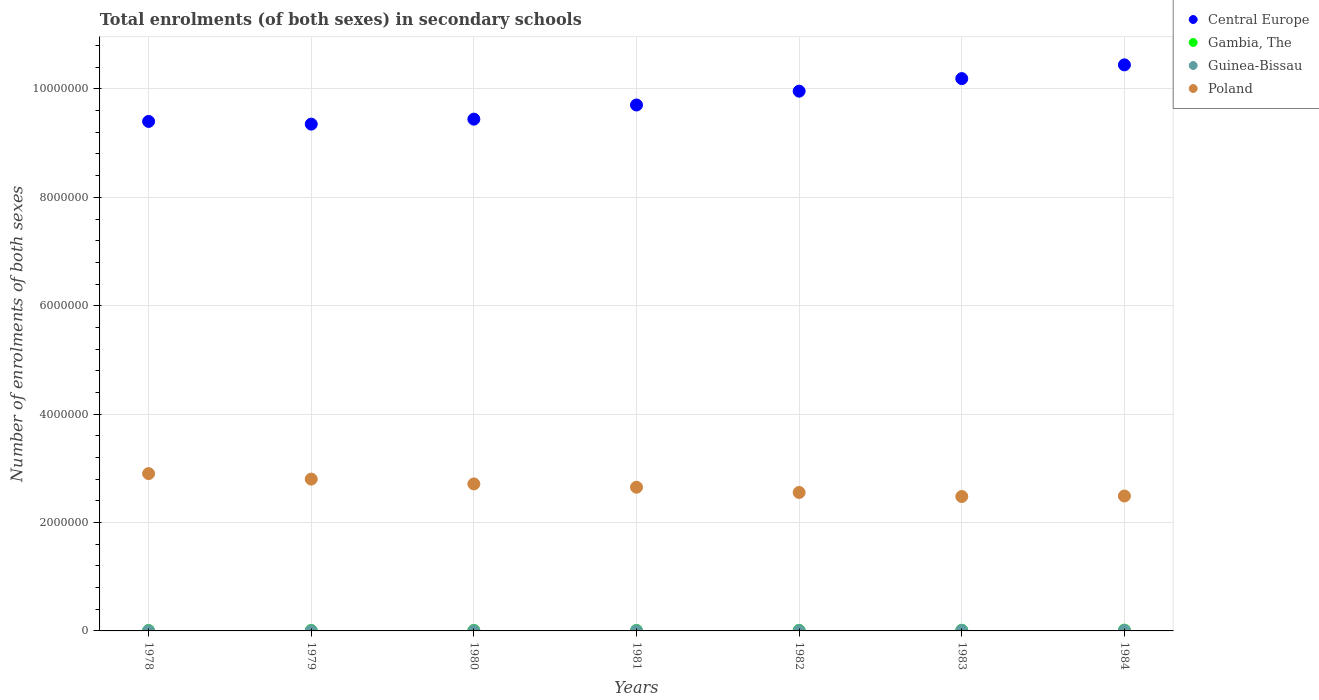How many different coloured dotlines are there?
Give a very brief answer. 4. Is the number of dotlines equal to the number of legend labels?
Offer a very short reply. Yes. What is the number of enrolments in secondary schools in Gambia, The in 1983?
Offer a very short reply. 1.24e+04. Across all years, what is the maximum number of enrolments in secondary schools in Gambia, The?
Ensure brevity in your answer.  1.44e+04. Across all years, what is the minimum number of enrolments in secondary schools in Central Europe?
Offer a terse response. 9.35e+06. In which year was the number of enrolments in secondary schools in Guinea-Bissau maximum?
Keep it short and to the point. 1984. In which year was the number of enrolments in secondary schools in Poland minimum?
Keep it short and to the point. 1983. What is the total number of enrolments in secondary schools in Central Europe in the graph?
Give a very brief answer. 6.85e+07. What is the difference between the number of enrolments in secondary schools in Guinea-Bissau in 1979 and that in 1983?
Make the answer very short. -4142. What is the difference between the number of enrolments in secondary schools in Central Europe in 1979 and the number of enrolments in secondary schools in Gambia, The in 1982?
Offer a very short reply. 9.34e+06. What is the average number of enrolments in secondary schools in Gambia, The per year?
Offer a very short reply. 1.02e+04. In the year 1983, what is the difference between the number of enrolments in secondary schools in Poland and number of enrolments in secondary schools in Central Europe?
Keep it short and to the point. -7.71e+06. In how many years, is the number of enrolments in secondary schools in Guinea-Bissau greater than 6000000?
Ensure brevity in your answer.  0. What is the ratio of the number of enrolments in secondary schools in Gambia, The in 1978 to that in 1982?
Offer a very short reply. 0.72. Is the difference between the number of enrolments in secondary schools in Poland in 1981 and 1984 greater than the difference between the number of enrolments in secondary schools in Central Europe in 1981 and 1984?
Your response must be concise. Yes. What is the difference between the highest and the second highest number of enrolments in secondary schools in Poland?
Make the answer very short. 1.01e+05. What is the difference between the highest and the lowest number of enrolments in secondary schools in Poland?
Provide a succinct answer. 4.22e+05. Is the sum of the number of enrolments in secondary schools in Gambia, The in 1978 and 1979 greater than the maximum number of enrolments in secondary schools in Poland across all years?
Offer a terse response. No. Is it the case that in every year, the sum of the number of enrolments in secondary schools in Guinea-Bissau and number of enrolments in secondary schools in Gambia, The  is greater than the number of enrolments in secondary schools in Central Europe?
Give a very brief answer. No. Does the number of enrolments in secondary schools in Gambia, The monotonically increase over the years?
Your answer should be very brief. Yes. Is the number of enrolments in secondary schools in Central Europe strictly greater than the number of enrolments in secondary schools in Guinea-Bissau over the years?
Offer a very short reply. Yes. Is the number of enrolments in secondary schools in Poland strictly less than the number of enrolments in secondary schools in Central Europe over the years?
Your answer should be compact. Yes. How many dotlines are there?
Ensure brevity in your answer.  4. How many years are there in the graph?
Your answer should be compact. 7. Does the graph contain any zero values?
Provide a short and direct response. No. Where does the legend appear in the graph?
Keep it short and to the point. Top right. How many legend labels are there?
Offer a very short reply. 4. How are the legend labels stacked?
Offer a very short reply. Vertical. What is the title of the graph?
Make the answer very short. Total enrolments (of both sexes) in secondary schools. Does "Saudi Arabia" appear as one of the legend labels in the graph?
Your response must be concise. No. What is the label or title of the X-axis?
Your response must be concise. Years. What is the label or title of the Y-axis?
Keep it short and to the point. Number of enrolments of both sexes. What is the Number of enrolments of both sexes in Central Europe in 1978?
Make the answer very short. 9.40e+06. What is the Number of enrolments of both sexes in Gambia, The in 1978?
Provide a succinct answer. 7588. What is the Number of enrolments of both sexes in Guinea-Bissau in 1978?
Keep it short and to the point. 3731. What is the Number of enrolments of both sexes of Poland in 1978?
Offer a very short reply. 2.90e+06. What is the Number of enrolments of both sexes of Central Europe in 1979?
Offer a terse response. 9.35e+06. What is the Number of enrolments of both sexes in Gambia, The in 1979?
Offer a terse response. 8101. What is the Number of enrolments of both sexes of Guinea-Bissau in 1979?
Make the answer very short. 4290. What is the Number of enrolments of both sexes in Poland in 1979?
Offer a terse response. 2.80e+06. What is the Number of enrolments of both sexes in Central Europe in 1980?
Give a very brief answer. 9.44e+06. What is the Number of enrolments of both sexes of Gambia, The in 1980?
Provide a short and direct response. 8940. What is the Number of enrolments of both sexes of Guinea-Bissau in 1980?
Ensure brevity in your answer.  4256. What is the Number of enrolments of both sexes in Poland in 1980?
Your response must be concise. 2.71e+06. What is the Number of enrolments of both sexes in Central Europe in 1981?
Offer a terse response. 9.70e+06. What is the Number of enrolments of both sexes of Gambia, The in 1981?
Keep it short and to the point. 9657. What is the Number of enrolments of both sexes of Guinea-Bissau in 1981?
Your answer should be very brief. 4757. What is the Number of enrolments of both sexes of Poland in 1981?
Keep it short and to the point. 2.65e+06. What is the Number of enrolments of both sexes of Central Europe in 1982?
Give a very brief answer. 9.96e+06. What is the Number of enrolments of both sexes of Gambia, The in 1982?
Keep it short and to the point. 1.06e+04. What is the Number of enrolments of both sexes in Guinea-Bissau in 1982?
Offer a terse response. 6294. What is the Number of enrolments of both sexes of Poland in 1982?
Offer a very short reply. 2.55e+06. What is the Number of enrolments of both sexes of Central Europe in 1983?
Make the answer very short. 1.02e+07. What is the Number of enrolments of both sexes of Gambia, The in 1983?
Keep it short and to the point. 1.24e+04. What is the Number of enrolments of both sexes in Guinea-Bissau in 1983?
Your answer should be very brief. 8432. What is the Number of enrolments of both sexes in Poland in 1983?
Your answer should be compact. 2.48e+06. What is the Number of enrolments of both sexes in Central Europe in 1984?
Your answer should be compact. 1.04e+07. What is the Number of enrolments of both sexes of Gambia, The in 1984?
Your answer should be compact. 1.44e+04. What is the Number of enrolments of both sexes of Guinea-Bissau in 1984?
Your answer should be very brief. 9634. What is the Number of enrolments of both sexes in Poland in 1984?
Ensure brevity in your answer.  2.49e+06. Across all years, what is the maximum Number of enrolments of both sexes of Central Europe?
Your answer should be very brief. 1.04e+07. Across all years, what is the maximum Number of enrolments of both sexes of Gambia, The?
Provide a short and direct response. 1.44e+04. Across all years, what is the maximum Number of enrolments of both sexes in Guinea-Bissau?
Provide a succinct answer. 9634. Across all years, what is the maximum Number of enrolments of both sexes of Poland?
Give a very brief answer. 2.90e+06. Across all years, what is the minimum Number of enrolments of both sexes of Central Europe?
Keep it short and to the point. 9.35e+06. Across all years, what is the minimum Number of enrolments of both sexes of Gambia, The?
Offer a very short reply. 7588. Across all years, what is the minimum Number of enrolments of both sexes in Guinea-Bissau?
Make the answer very short. 3731. Across all years, what is the minimum Number of enrolments of both sexes in Poland?
Your answer should be compact. 2.48e+06. What is the total Number of enrolments of both sexes in Central Europe in the graph?
Provide a succinct answer. 6.85e+07. What is the total Number of enrolments of both sexes of Gambia, The in the graph?
Ensure brevity in your answer.  7.17e+04. What is the total Number of enrolments of both sexes in Guinea-Bissau in the graph?
Make the answer very short. 4.14e+04. What is the total Number of enrolments of both sexes of Poland in the graph?
Offer a very short reply. 1.86e+07. What is the difference between the Number of enrolments of both sexes of Central Europe in 1978 and that in 1979?
Provide a short and direct response. 4.96e+04. What is the difference between the Number of enrolments of both sexes in Gambia, The in 1978 and that in 1979?
Ensure brevity in your answer.  -513. What is the difference between the Number of enrolments of both sexes in Guinea-Bissau in 1978 and that in 1979?
Ensure brevity in your answer.  -559. What is the difference between the Number of enrolments of both sexes of Poland in 1978 and that in 1979?
Your answer should be very brief. 1.01e+05. What is the difference between the Number of enrolments of both sexes in Central Europe in 1978 and that in 1980?
Make the answer very short. -4.21e+04. What is the difference between the Number of enrolments of both sexes of Gambia, The in 1978 and that in 1980?
Provide a short and direct response. -1352. What is the difference between the Number of enrolments of both sexes in Guinea-Bissau in 1978 and that in 1980?
Ensure brevity in your answer.  -525. What is the difference between the Number of enrolments of both sexes of Poland in 1978 and that in 1980?
Give a very brief answer. 1.90e+05. What is the difference between the Number of enrolments of both sexes in Central Europe in 1978 and that in 1981?
Make the answer very short. -3.03e+05. What is the difference between the Number of enrolments of both sexes of Gambia, The in 1978 and that in 1981?
Give a very brief answer. -2069. What is the difference between the Number of enrolments of both sexes of Guinea-Bissau in 1978 and that in 1981?
Provide a short and direct response. -1026. What is the difference between the Number of enrolments of both sexes in Poland in 1978 and that in 1981?
Provide a short and direct response. 2.51e+05. What is the difference between the Number of enrolments of both sexes in Central Europe in 1978 and that in 1982?
Provide a short and direct response. -5.59e+05. What is the difference between the Number of enrolments of both sexes in Gambia, The in 1978 and that in 1982?
Provide a succinct answer. -2981. What is the difference between the Number of enrolments of both sexes in Guinea-Bissau in 1978 and that in 1982?
Offer a terse response. -2563. What is the difference between the Number of enrolments of both sexes in Poland in 1978 and that in 1982?
Your answer should be compact. 3.48e+05. What is the difference between the Number of enrolments of both sexes of Central Europe in 1978 and that in 1983?
Your answer should be very brief. -7.90e+05. What is the difference between the Number of enrolments of both sexes in Gambia, The in 1978 and that in 1983?
Make the answer very short. -4836. What is the difference between the Number of enrolments of both sexes of Guinea-Bissau in 1978 and that in 1983?
Ensure brevity in your answer.  -4701. What is the difference between the Number of enrolments of both sexes in Poland in 1978 and that in 1983?
Provide a short and direct response. 4.22e+05. What is the difference between the Number of enrolments of both sexes of Central Europe in 1978 and that in 1984?
Provide a short and direct response. -1.04e+06. What is the difference between the Number of enrolments of both sexes in Gambia, The in 1978 and that in 1984?
Your answer should be compact. -6842. What is the difference between the Number of enrolments of both sexes in Guinea-Bissau in 1978 and that in 1984?
Offer a terse response. -5903. What is the difference between the Number of enrolments of both sexes in Poland in 1978 and that in 1984?
Make the answer very short. 4.13e+05. What is the difference between the Number of enrolments of both sexes of Central Europe in 1979 and that in 1980?
Give a very brief answer. -9.18e+04. What is the difference between the Number of enrolments of both sexes in Gambia, The in 1979 and that in 1980?
Your response must be concise. -839. What is the difference between the Number of enrolments of both sexes in Poland in 1979 and that in 1980?
Provide a short and direct response. 8.89e+04. What is the difference between the Number of enrolments of both sexes in Central Europe in 1979 and that in 1981?
Offer a very short reply. -3.53e+05. What is the difference between the Number of enrolments of both sexes in Gambia, The in 1979 and that in 1981?
Ensure brevity in your answer.  -1556. What is the difference between the Number of enrolments of both sexes of Guinea-Bissau in 1979 and that in 1981?
Give a very brief answer. -467. What is the difference between the Number of enrolments of both sexes of Poland in 1979 and that in 1981?
Your answer should be compact. 1.50e+05. What is the difference between the Number of enrolments of both sexes in Central Europe in 1979 and that in 1982?
Keep it short and to the point. -6.08e+05. What is the difference between the Number of enrolments of both sexes in Gambia, The in 1979 and that in 1982?
Provide a short and direct response. -2468. What is the difference between the Number of enrolments of both sexes in Guinea-Bissau in 1979 and that in 1982?
Offer a terse response. -2004. What is the difference between the Number of enrolments of both sexes of Poland in 1979 and that in 1982?
Your response must be concise. 2.47e+05. What is the difference between the Number of enrolments of both sexes of Central Europe in 1979 and that in 1983?
Provide a succinct answer. -8.40e+05. What is the difference between the Number of enrolments of both sexes of Gambia, The in 1979 and that in 1983?
Your response must be concise. -4323. What is the difference between the Number of enrolments of both sexes in Guinea-Bissau in 1979 and that in 1983?
Provide a succinct answer. -4142. What is the difference between the Number of enrolments of both sexes in Poland in 1979 and that in 1983?
Your response must be concise. 3.21e+05. What is the difference between the Number of enrolments of both sexes of Central Europe in 1979 and that in 1984?
Provide a short and direct response. -1.09e+06. What is the difference between the Number of enrolments of both sexes of Gambia, The in 1979 and that in 1984?
Keep it short and to the point. -6329. What is the difference between the Number of enrolments of both sexes in Guinea-Bissau in 1979 and that in 1984?
Your answer should be compact. -5344. What is the difference between the Number of enrolments of both sexes in Poland in 1979 and that in 1984?
Your answer should be compact. 3.12e+05. What is the difference between the Number of enrolments of both sexes in Central Europe in 1980 and that in 1981?
Offer a very short reply. -2.61e+05. What is the difference between the Number of enrolments of both sexes of Gambia, The in 1980 and that in 1981?
Provide a succinct answer. -717. What is the difference between the Number of enrolments of both sexes in Guinea-Bissau in 1980 and that in 1981?
Offer a very short reply. -501. What is the difference between the Number of enrolments of both sexes of Poland in 1980 and that in 1981?
Ensure brevity in your answer.  6.11e+04. What is the difference between the Number of enrolments of both sexes of Central Europe in 1980 and that in 1982?
Keep it short and to the point. -5.16e+05. What is the difference between the Number of enrolments of both sexes in Gambia, The in 1980 and that in 1982?
Offer a very short reply. -1629. What is the difference between the Number of enrolments of both sexes in Guinea-Bissau in 1980 and that in 1982?
Give a very brief answer. -2038. What is the difference between the Number of enrolments of both sexes in Poland in 1980 and that in 1982?
Give a very brief answer. 1.58e+05. What is the difference between the Number of enrolments of both sexes of Central Europe in 1980 and that in 1983?
Keep it short and to the point. -7.48e+05. What is the difference between the Number of enrolments of both sexes of Gambia, The in 1980 and that in 1983?
Offer a very short reply. -3484. What is the difference between the Number of enrolments of both sexes in Guinea-Bissau in 1980 and that in 1983?
Offer a very short reply. -4176. What is the difference between the Number of enrolments of both sexes of Poland in 1980 and that in 1983?
Give a very brief answer. 2.32e+05. What is the difference between the Number of enrolments of both sexes in Central Europe in 1980 and that in 1984?
Give a very brief answer. -1.00e+06. What is the difference between the Number of enrolments of both sexes of Gambia, The in 1980 and that in 1984?
Your response must be concise. -5490. What is the difference between the Number of enrolments of both sexes in Guinea-Bissau in 1980 and that in 1984?
Make the answer very short. -5378. What is the difference between the Number of enrolments of both sexes in Poland in 1980 and that in 1984?
Ensure brevity in your answer.  2.23e+05. What is the difference between the Number of enrolments of both sexes in Central Europe in 1981 and that in 1982?
Make the answer very short. -2.55e+05. What is the difference between the Number of enrolments of both sexes of Gambia, The in 1981 and that in 1982?
Your response must be concise. -912. What is the difference between the Number of enrolments of both sexes in Guinea-Bissau in 1981 and that in 1982?
Your response must be concise. -1537. What is the difference between the Number of enrolments of both sexes of Poland in 1981 and that in 1982?
Your response must be concise. 9.65e+04. What is the difference between the Number of enrolments of both sexes in Central Europe in 1981 and that in 1983?
Offer a terse response. -4.87e+05. What is the difference between the Number of enrolments of both sexes of Gambia, The in 1981 and that in 1983?
Provide a succinct answer. -2767. What is the difference between the Number of enrolments of both sexes in Guinea-Bissau in 1981 and that in 1983?
Your answer should be compact. -3675. What is the difference between the Number of enrolments of both sexes in Poland in 1981 and that in 1983?
Give a very brief answer. 1.71e+05. What is the difference between the Number of enrolments of both sexes of Central Europe in 1981 and that in 1984?
Provide a short and direct response. -7.40e+05. What is the difference between the Number of enrolments of both sexes of Gambia, The in 1981 and that in 1984?
Your answer should be compact. -4773. What is the difference between the Number of enrolments of both sexes in Guinea-Bissau in 1981 and that in 1984?
Your answer should be very brief. -4877. What is the difference between the Number of enrolments of both sexes in Poland in 1981 and that in 1984?
Your answer should be very brief. 1.62e+05. What is the difference between the Number of enrolments of both sexes in Central Europe in 1982 and that in 1983?
Your response must be concise. -2.32e+05. What is the difference between the Number of enrolments of both sexes of Gambia, The in 1982 and that in 1983?
Your answer should be very brief. -1855. What is the difference between the Number of enrolments of both sexes of Guinea-Bissau in 1982 and that in 1983?
Keep it short and to the point. -2138. What is the difference between the Number of enrolments of both sexes of Poland in 1982 and that in 1983?
Your response must be concise. 7.42e+04. What is the difference between the Number of enrolments of both sexes in Central Europe in 1982 and that in 1984?
Make the answer very short. -4.85e+05. What is the difference between the Number of enrolments of both sexes of Gambia, The in 1982 and that in 1984?
Provide a short and direct response. -3861. What is the difference between the Number of enrolments of both sexes of Guinea-Bissau in 1982 and that in 1984?
Make the answer very short. -3340. What is the difference between the Number of enrolments of both sexes of Poland in 1982 and that in 1984?
Make the answer very short. 6.54e+04. What is the difference between the Number of enrolments of both sexes in Central Europe in 1983 and that in 1984?
Make the answer very short. -2.53e+05. What is the difference between the Number of enrolments of both sexes in Gambia, The in 1983 and that in 1984?
Keep it short and to the point. -2006. What is the difference between the Number of enrolments of both sexes in Guinea-Bissau in 1983 and that in 1984?
Provide a short and direct response. -1202. What is the difference between the Number of enrolments of both sexes of Poland in 1983 and that in 1984?
Your answer should be very brief. -8840. What is the difference between the Number of enrolments of both sexes of Central Europe in 1978 and the Number of enrolments of both sexes of Gambia, The in 1979?
Provide a succinct answer. 9.39e+06. What is the difference between the Number of enrolments of both sexes in Central Europe in 1978 and the Number of enrolments of both sexes in Guinea-Bissau in 1979?
Your response must be concise. 9.40e+06. What is the difference between the Number of enrolments of both sexes in Central Europe in 1978 and the Number of enrolments of both sexes in Poland in 1979?
Give a very brief answer. 6.60e+06. What is the difference between the Number of enrolments of both sexes in Gambia, The in 1978 and the Number of enrolments of both sexes in Guinea-Bissau in 1979?
Your response must be concise. 3298. What is the difference between the Number of enrolments of both sexes in Gambia, The in 1978 and the Number of enrolments of both sexes in Poland in 1979?
Give a very brief answer. -2.79e+06. What is the difference between the Number of enrolments of both sexes in Guinea-Bissau in 1978 and the Number of enrolments of both sexes in Poland in 1979?
Give a very brief answer. -2.80e+06. What is the difference between the Number of enrolments of both sexes in Central Europe in 1978 and the Number of enrolments of both sexes in Gambia, The in 1980?
Your response must be concise. 9.39e+06. What is the difference between the Number of enrolments of both sexes in Central Europe in 1978 and the Number of enrolments of both sexes in Guinea-Bissau in 1980?
Provide a succinct answer. 9.40e+06. What is the difference between the Number of enrolments of both sexes in Central Europe in 1978 and the Number of enrolments of both sexes in Poland in 1980?
Provide a succinct answer. 6.69e+06. What is the difference between the Number of enrolments of both sexes in Gambia, The in 1978 and the Number of enrolments of both sexes in Guinea-Bissau in 1980?
Your answer should be compact. 3332. What is the difference between the Number of enrolments of both sexes of Gambia, The in 1978 and the Number of enrolments of both sexes of Poland in 1980?
Your answer should be very brief. -2.70e+06. What is the difference between the Number of enrolments of both sexes of Guinea-Bissau in 1978 and the Number of enrolments of both sexes of Poland in 1980?
Ensure brevity in your answer.  -2.71e+06. What is the difference between the Number of enrolments of both sexes in Central Europe in 1978 and the Number of enrolments of both sexes in Gambia, The in 1981?
Your response must be concise. 9.39e+06. What is the difference between the Number of enrolments of both sexes of Central Europe in 1978 and the Number of enrolments of both sexes of Guinea-Bissau in 1981?
Your answer should be compact. 9.40e+06. What is the difference between the Number of enrolments of both sexes of Central Europe in 1978 and the Number of enrolments of both sexes of Poland in 1981?
Provide a short and direct response. 6.75e+06. What is the difference between the Number of enrolments of both sexes of Gambia, The in 1978 and the Number of enrolments of both sexes of Guinea-Bissau in 1981?
Offer a terse response. 2831. What is the difference between the Number of enrolments of both sexes in Gambia, The in 1978 and the Number of enrolments of both sexes in Poland in 1981?
Your response must be concise. -2.64e+06. What is the difference between the Number of enrolments of both sexes of Guinea-Bissau in 1978 and the Number of enrolments of both sexes of Poland in 1981?
Offer a very short reply. -2.65e+06. What is the difference between the Number of enrolments of both sexes in Central Europe in 1978 and the Number of enrolments of both sexes in Gambia, The in 1982?
Make the answer very short. 9.39e+06. What is the difference between the Number of enrolments of both sexes in Central Europe in 1978 and the Number of enrolments of both sexes in Guinea-Bissau in 1982?
Offer a terse response. 9.39e+06. What is the difference between the Number of enrolments of both sexes of Central Europe in 1978 and the Number of enrolments of both sexes of Poland in 1982?
Offer a very short reply. 6.85e+06. What is the difference between the Number of enrolments of both sexes in Gambia, The in 1978 and the Number of enrolments of both sexes in Guinea-Bissau in 1982?
Keep it short and to the point. 1294. What is the difference between the Number of enrolments of both sexes in Gambia, The in 1978 and the Number of enrolments of both sexes in Poland in 1982?
Make the answer very short. -2.55e+06. What is the difference between the Number of enrolments of both sexes in Guinea-Bissau in 1978 and the Number of enrolments of both sexes in Poland in 1982?
Your response must be concise. -2.55e+06. What is the difference between the Number of enrolments of both sexes of Central Europe in 1978 and the Number of enrolments of both sexes of Gambia, The in 1983?
Your answer should be compact. 9.39e+06. What is the difference between the Number of enrolments of both sexes of Central Europe in 1978 and the Number of enrolments of both sexes of Guinea-Bissau in 1983?
Provide a short and direct response. 9.39e+06. What is the difference between the Number of enrolments of both sexes in Central Europe in 1978 and the Number of enrolments of both sexes in Poland in 1983?
Keep it short and to the point. 6.92e+06. What is the difference between the Number of enrolments of both sexes in Gambia, The in 1978 and the Number of enrolments of both sexes in Guinea-Bissau in 1983?
Your response must be concise. -844. What is the difference between the Number of enrolments of both sexes in Gambia, The in 1978 and the Number of enrolments of both sexes in Poland in 1983?
Make the answer very short. -2.47e+06. What is the difference between the Number of enrolments of both sexes in Guinea-Bissau in 1978 and the Number of enrolments of both sexes in Poland in 1983?
Offer a very short reply. -2.48e+06. What is the difference between the Number of enrolments of both sexes in Central Europe in 1978 and the Number of enrolments of both sexes in Gambia, The in 1984?
Keep it short and to the point. 9.39e+06. What is the difference between the Number of enrolments of both sexes in Central Europe in 1978 and the Number of enrolments of both sexes in Guinea-Bissau in 1984?
Provide a succinct answer. 9.39e+06. What is the difference between the Number of enrolments of both sexes in Central Europe in 1978 and the Number of enrolments of both sexes in Poland in 1984?
Your answer should be very brief. 6.91e+06. What is the difference between the Number of enrolments of both sexes in Gambia, The in 1978 and the Number of enrolments of both sexes in Guinea-Bissau in 1984?
Your answer should be very brief. -2046. What is the difference between the Number of enrolments of both sexes in Gambia, The in 1978 and the Number of enrolments of both sexes in Poland in 1984?
Give a very brief answer. -2.48e+06. What is the difference between the Number of enrolments of both sexes of Guinea-Bissau in 1978 and the Number of enrolments of both sexes of Poland in 1984?
Your answer should be very brief. -2.49e+06. What is the difference between the Number of enrolments of both sexes of Central Europe in 1979 and the Number of enrolments of both sexes of Gambia, The in 1980?
Offer a very short reply. 9.34e+06. What is the difference between the Number of enrolments of both sexes of Central Europe in 1979 and the Number of enrolments of both sexes of Guinea-Bissau in 1980?
Offer a terse response. 9.35e+06. What is the difference between the Number of enrolments of both sexes in Central Europe in 1979 and the Number of enrolments of both sexes in Poland in 1980?
Provide a succinct answer. 6.64e+06. What is the difference between the Number of enrolments of both sexes in Gambia, The in 1979 and the Number of enrolments of both sexes in Guinea-Bissau in 1980?
Your response must be concise. 3845. What is the difference between the Number of enrolments of both sexes of Gambia, The in 1979 and the Number of enrolments of both sexes of Poland in 1980?
Give a very brief answer. -2.70e+06. What is the difference between the Number of enrolments of both sexes in Guinea-Bissau in 1979 and the Number of enrolments of both sexes in Poland in 1980?
Keep it short and to the point. -2.71e+06. What is the difference between the Number of enrolments of both sexes of Central Europe in 1979 and the Number of enrolments of both sexes of Gambia, The in 1981?
Your answer should be very brief. 9.34e+06. What is the difference between the Number of enrolments of both sexes in Central Europe in 1979 and the Number of enrolments of both sexes in Guinea-Bissau in 1981?
Give a very brief answer. 9.35e+06. What is the difference between the Number of enrolments of both sexes of Central Europe in 1979 and the Number of enrolments of both sexes of Poland in 1981?
Provide a short and direct response. 6.70e+06. What is the difference between the Number of enrolments of both sexes in Gambia, The in 1979 and the Number of enrolments of both sexes in Guinea-Bissau in 1981?
Keep it short and to the point. 3344. What is the difference between the Number of enrolments of both sexes in Gambia, The in 1979 and the Number of enrolments of both sexes in Poland in 1981?
Provide a short and direct response. -2.64e+06. What is the difference between the Number of enrolments of both sexes of Guinea-Bissau in 1979 and the Number of enrolments of both sexes of Poland in 1981?
Ensure brevity in your answer.  -2.65e+06. What is the difference between the Number of enrolments of both sexes of Central Europe in 1979 and the Number of enrolments of both sexes of Gambia, The in 1982?
Make the answer very short. 9.34e+06. What is the difference between the Number of enrolments of both sexes in Central Europe in 1979 and the Number of enrolments of both sexes in Guinea-Bissau in 1982?
Provide a short and direct response. 9.34e+06. What is the difference between the Number of enrolments of both sexes in Central Europe in 1979 and the Number of enrolments of both sexes in Poland in 1982?
Your answer should be very brief. 6.80e+06. What is the difference between the Number of enrolments of both sexes of Gambia, The in 1979 and the Number of enrolments of both sexes of Guinea-Bissau in 1982?
Provide a short and direct response. 1807. What is the difference between the Number of enrolments of both sexes of Gambia, The in 1979 and the Number of enrolments of both sexes of Poland in 1982?
Your answer should be compact. -2.55e+06. What is the difference between the Number of enrolments of both sexes in Guinea-Bissau in 1979 and the Number of enrolments of both sexes in Poland in 1982?
Ensure brevity in your answer.  -2.55e+06. What is the difference between the Number of enrolments of both sexes in Central Europe in 1979 and the Number of enrolments of both sexes in Gambia, The in 1983?
Your response must be concise. 9.34e+06. What is the difference between the Number of enrolments of both sexes of Central Europe in 1979 and the Number of enrolments of both sexes of Guinea-Bissau in 1983?
Your response must be concise. 9.34e+06. What is the difference between the Number of enrolments of both sexes of Central Europe in 1979 and the Number of enrolments of both sexes of Poland in 1983?
Provide a succinct answer. 6.87e+06. What is the difference between the Number of enrolments of both sexes in Gambia, The in 1979 and the Number of enrolments of both sexes in Guinea-Bissau in 1983?
Provide a succinct answer. -331. What is the difference between the Number of enrolments of both sexes of Gambia, The in 1979 and the Number of enrolments of both sexes of Poland in 1983?
Your response must be concise. -2.47e+06. What is the difference between the Number of enrolments of both sexes in Guinea-Bissau in 1979 and the Number of enrolments of both sexes in Poland in 1983?
Ensure brevity in your answer.  -2.48e+06. What is the difference between the Number of enrolments of both sexes of Central Europe in 1979 and the Number of enrolments of both sexes of Gambia, The in 1984?
Make the answer very short. 9.34e+06. What is the difference between the Number of enrolments of both sexes in Central Europe in 1979 and the Number of enrolments of both sexes in Guinea-Bissau in 1984?
Offer a very short reply. 9.34e+06. What is the difference between the Number of enrolments of both sexes of Central Europe in 1979 and the Number of enrolments of both sexes of Poland in 1984?
Your answer should be compact. 6.86e+06. What is the difference between the Number of enrolments of both sexes in Gambia, The in 1979 and the Number of enrolments of both sexes in Guinea-Bissau in 1984?
Offer a terse response. -1533. What is the difference between the Number of enrolments of both sexes in Gambia, The in 1979 and the Number of enrolments of both sexes in Poland in 1984?
Provide a succinct answer. -2.48e+06. What is the difference between the Number of enrolments of both sexes in Guinea-Bissau in 1979 and the Number of enrolments of both sexes in Poland in 1984?
Your answer should be compact. -2.48e+06. What is the difference between the Number of enrolments of both sexes of Central Europe in 1980 and the Number of enrolments of both sexes of Gambia, The in 1981?
Make the answer very short. 9.43e+06. What is the difference between the Number of enrolments of both sexes of Central Europe in 1980 and the Number of enrolments of both sexes of Guinea-Bissau in 1981?
Make the answer very short. 9.44e+06. What is the difference between the Number of enrolments of both sexes of Central Europe in 1980 and the Number of enrolments of both sexes of Poland in 1981?
Your response must be concise. 6.79e+06. What is the difference between the Number of enrolments of both sexes of Gambia, The in 1980 and the Number of enrolments of both sexes of Guinea-Bissau in 1981?
Offer a very short reply. 4183. What is the difference between the Number of enrolments of both sexes of Gambia, The in 1980 and the Number of enrolments of both sexes of Poland in 1981?
Give a very brief answer. -2.64e+06. What is the difference between the Number of enrolments of both sexes of Guinea-Bissau in 1980 and the Number of enrolments of both sexes of Poland in 1981?
Offer a terse response. -2.65e+06. What is the difference between the Number of enrolments of both sexes in Central Europe in 1980 and the Number of enrolments of both sexes in Gambia, The in 1982?
Keep it short and to the point. 9.43e+06. What is the difference between the Number of enrolments of both sexes in Central Europe in 1980 and the Number of enrolments of both sexes in Guinea-Bissau in 1982?
Your answer should be compact. 9.44e+06. What is the difference between the Number of enrolments of both sexes of Central Europe in 1980 and the Number of enrolments of both sexes of Poland in 1982?
Provide a short and direct response. 6.89e+06. What is the difference between the Number of enrolments of both sexes of Gambia, The in 1980 and the Number of enrolments of both sexes of Guinea-Bissau in 1982?
Your answer should be very brief. 2646. What is the difference between the Number of enrolments of both sexes in Gambia, The in 1980 and the Number of enrolments of both sexes in Poland in 1982?
Your response must be concise. -2.55e+06. What is the difference between the Number of enrolments of both sexes in Guinea-Bissau in 1980 and the Number of enrolments of both sexes in Poland in 1982?
Make the answer very short. -2.55e+06. What is the difference between the Number of enrolments of both sexes of Central Europe in 1980 and the Number of enrolments of both sexes of Gambia, The in 1983?
Offer a terse response. 9.43e+06. What is the difference between the Number of enrolments of both sexes of Central Europe in 1980 and the Number of enrolments of both sexes of Guinea-Bissau in 1983?
Your answer should be very brief. 9.43e+06. What is the difference between the Number of enrolments of both sexes in Central Europe in 1980 and the Number of enrolments of both sexes in Poland in 1983?
Your answer should be very brief. 6.96e+06. What is the difference between the Number of enrolments of both sexes of Gambia, The in 1980 and the Number of enrolments of both sexes of Guinea-Bissau in 1983?
Your answer should be compact. 508. What is the difference between the Number of enrolments of both sexes in Gambia, The in 1980 and the Number of enrolments of both sexes in Poland in 1983?
Make the answer very short. -2.47e+06. What is the difference between the Number of enrolments of both sexes in Guinea-Bissau in 1980 and the Number of enrolments of both sexes in Poland in 1983?
Offer a very short reply. -2.48e+06. What is the difference between the Number of enrolments of both sexes in Central Europe in 1980 and the Number of enrolments of both sexes in Gambia, The in 1984?
Give a very brief answer. 9.43e+06. What is the difference between the Number of enrolments of both sexes in Central Europe in 1980 and the Number of enrolments of both sexes in Guinea-Bissau in 1984?
Offer a very short reply. 9.43e+06. What is the difference between the Number of enrolments of both sexes of Central Europe in 1980 and the Number of enrolments of both sexes of Poland in 1984?
Provide a succinct answer. 6.95e+06. What is the difference between the Number of enrolments of both sexes in Gambia, The in 1980 and the Number of enrolments of both sexes in Guinea-Bissau in 1984?
Give a very brief answer. -694. What is the difference between the Number of enrolments of both sexes in Gambia, The in 1980 and the Number of enrolments of both sexes in Poland in 1984?
Provide a short and direct response. -2.48e+06. What is the difference between the Number of enrolments of both sexes in Guinea-Bissau in 1980 and the Number of enrolments of both sexes in Poland in 1984?
Make the answer very short. -2.48e+06. What is the difference between the Number of enrolments of both sexes of Central Europe in 1981 and the Number of enrolments of both sexes of Gambia, The in 1982?
Ensure brevity in your answer.  9.69e+06. What is the difference between the Number of enrolments of both sexes in Central Europe in 1981 and the Number of enrolments of both sexes in Guinea-Bissau in 1982?
Ensure brevity in your answer.  9.70e+06. What is the difference between the Number of enrolments of both sexes in Central Europe in 1981 and the Number of enrolments of both sexes in Poland in 1982?
Make the answer very short. 7.15e+06. What is the difference between the Number of enrolments of both sexes of Gambia, The in 1981 and the Number of enrolments of both sexes of Guinea-Bissau in 1982?
Provide a succinct answer. 3363. What is the difference between the Number of enrolments of both sexes of Gambia, The in 1981 and the Number of enrolments of both sexes of Poland in 1982?
Give a very brief answer. -2.54e+06. What is the difference between the Number of enrolments of both sexes in Guinea-Bissau in 1981 and the Number of enrolments of both sexes in Poland in 1982?
Provide a succinct answer. -2.55e+06. What is the difference between the Number of enrolments of both sexes of Central Europe in 1981 and the Number of enrolments of both sexes of Gambia, The in 1983?
Your response must be concise. 9.69e+06. What is the difference between the Number of enrolments of both sexes of Central Europe in 1981 and the Number of enrolments of both sexes of Guinea-Bissau in 1983?
Make the answer very short. 9.70e+06. What is the difference between the Number of enrolments of both sexes in Central Europe in 1981 and the Number of enrolments of both sexes in Poland in 1983?
Provide a succinct answer. 7.22e+06. What is the difference between the Number of enrolments of both sexes of Gambia, The in 1981 and the Number of enrolments of both sexes of Guinea-Bissau in 1983?
Provide a succinct answer. 1225. What is the difference between the Number of enrolments of both sexes of Gambia, The in 1981 and the Number of enrolments of both sexes of Poland in 1983?
Your response must be concise. -2.47e+06. What is the difference between the Number of enrolments of both sexes of Guinea-Bissau in 1981 and the Number of enrolments of both sexes of Poland in 1983?
Your response must be concise. -2.48e+06. What is the difference between the Number of enrolments of both sexes of Central Europe in 1981 and the Number of enrolments of both sexes of Gambia, The in 1984?
Your answer should be very brief. 9.69e+06. What is the difference between the Number of enrolments of both sexes of Central Europe in 1981 and the Number of enrolments of both sexes of Guinea-Bissau in 1984?
Your response must be concise. 9.69e+06. What is the difference between the Number of enrolments of both sexes in Central Europe in 1981 and the Number of enrolments of both sexes in Poland in 1984?
Give a very brief answer. 7.21e+06. What is the difference between the Number of enrolments of both sexes in Gambia, The in 1981 and the Number of enrolments of both sexes in Poland in 1984?
Offer a very short reply. -2.48e+06. What is the difference between the Number of enrolments of both sexes in Guinea-Bissau in 1981 and the Number of enrolments of both sexes in Poland in 1984?
Offer a terse response. -2.48e+06. What is the difference between the Number of enrolments of both sexes in Central Europe in 1982 and the Number of enrolments of both sexes in Gambia, The in 1983?
Keep it short and to the point. 9.95e+06. What is the difference between the Number of enrolments of both sexes of Central Europe in 1982 and the Number of enrolments of both sexes of Guinea-Bissau in 1983?
Ensure brevity in your answer.  9.95e+06. What is the difference between the Number of enrolments of both sexes in Central Europe in 1982 and the Number of enrolments of both sexes in Poland in 1983?
Make the answer very short. 7.48e+06. What is the difference between the Number of enrolments of both sexes of Gambia, The in 1982 and the Number of enrolments of both sexes of Guinea-Bissau in 1983?
Offer a very short reply. 2137. What is the difference between the Number of enrolments of both sexes of Gambia, The in 1982 and the Number of enrolments of both sexes of Poland in 1983?
Offer a very short reply. -2.47e+06. What is the difference between the Number of enrolments of both sexes of Guinea-Bissau in 1982 and the Number of enrolments of both sexes of Poland in 1983?
Make the answer very short. -2.47e+06. What is the difference between the Number of enrolments of both sexes in Central Europe in 1982 and the Number of enrolments of both sexes in Gambia, The in 1984?
Keep it short and to the point. 9.94e+06. What is the difference between the Number of enrolments of both sexes of Central Europe in 1982 and the Number of enrolments of both sexes of Guinea-Bissau in 1984?
Offer a very short reply. 9.95e+06. What is the difference between the Number of enrolments of both sexes of Central Europe in 1982 and the Number of enrolments of both sexes of Poland in 1984?
Your response must be concise. 7.47e+06. What is the difference between the Number of enrolments of both sexes of Gambia, The in 1982 and the Number of enrolments of both sexes of Guinea-Bissau in 1984?
Make the answer very short. 935. What is the difference between the Number of enrolments of both sexes of Gambia, The in 1982 and the Number of enrolments of both sexes of Poland in 1984?
Your answer should be very brief. -2.48e+06. What is the difference between the Number of enrolments of both sexes of Guinea-Bissau in 1982 and the Number of enrolments of both sexes of Poland in 1984?
Your answer should be very brief. -2.48e+06. What is the difference between the Number of enrolments of both sexes of Central Europe in 1983 and the Number of enrolments of both sexes of Gambia, The in 1984?
Your answer should be compact. 1.02e+07. What is the difference between the Number of enrolments of both sexes of Central Europe in 1983 and the Number of enrolments of both sexes of Guinea-Bissau in 1984?
Offer a terse response. 1.02e+07. What is the difference between the Number of enrolments of both sexes of Central Europe in 1983 and the Number of enrolments of both sexes of Poland in 1984?
Keep it short and to the point. 7.70e+06. What is the difference between the Number of enrolments of both sexes in Gambia, The in 1983 and the Number of enrolments of both sexes in Guinea-Bissau in 1984?
Ensure brevity in your answer.  2790. What is the difference between the Number of enrolments of both sexes of Gambia, The in 1983 and the Number of enrolments of both sexes of Poland in 1984?
Make the answer very short. -2.48e+06. What is the difference between the Number of enrolments of both sexes of Guinea-Bissau in 1983 and the Number of enrolments of both sexes of Poland in 1984?
Give a very brief answer. -2.48e+06. What is the average Number of enrolments of both sexes of Central Europe per year?
Your answer should be very brief. 9.78e+06. What is the average Number of enrolments of both sexes of Gambia, The per year?
Provide a succinct answer. 1.02e+04. What is the average Number of enrolments of both sexes in Guinea-Bissau per year?
Your answer should be very brief. 5913.43. What is the average Number of enrolments of both sexes of Poland per year?
Keep it short and to the point. 2.66e+06. In the year 1978, what is the difference between the Number of enrolments of both sexes of Central Europe and Number of enrolments of both sexes of Gambia, The?
Offer a very short reply. 9.39e+06. In the year 1978, what is the difference between the Number of enrolments of both sexes in Central Europe and Number of enrolments of both sexes in Guinea-Bissau?
Offer a very short reply. 9.40e+06. In the year 1978, what is the difference between the Number of enrolments of both sexes in Central Europe and Number of enrolments of both sexes in Poland?
Your answer should be compact. 6.50e+06. In the year 1978, what is the difference between the Number of enrolments of both sexes of Gambia, The and Number of enrolments of both sexes of Guinea-Bissau?
Provide a short and direct response. 3857. In the year 1978, what is the difference between the Number of enrolments of both sexes of Gambia, The and Number of enrolments of both sexes of Poland?
Give a very brief answer. -2.89e+06. In the year 1978, what is the difference between the Number of enrolments of both sexes in Guinea-Bissau and Number of enrolments of both sexes in Poland?
Provide a succinct answer. -2.90e+06. In the year 1979, what is the difference between the Number of enrolments of both sexes in Central Europe and Number of enrolments of both sexes in Gambia, The?
Make the answer very short. 9.34e+06. In the year 1979, what is the difference between the Number of enrolments of both sexes in Central Europe and Number of enrolments of both sexes in Guinea-Bissau?
Ensure brevity in your answer.  9.35e+06. In the year 1979, what is the difference between the Number of enrolments of both sexes of Central Europe and Number of enrolments of both sexes of Poland?
Make the answer very short. 6.55e+06. In the year 1979, what is the difference between the Number of enrolments of both sexes in Gambia, The and Number of enrolments of both sexes in Guinea-Bissau?
Your answer should be very brief. 3811. In the year 1979, what is the difference between the Number of enrolments of both sexes of Gambia, The and Number of enrolments of both sexes of Poland?
Your answer should be compact. -2.79e+06. In the year 1979, what is the difference between the Number of enrolments of both sexes in Guinea-Bissau and Number of enrolments of both sexes in Poland?
Make the answer very short. -2.80e+06. In the year 1980, what is the difference between the Number of enrolments of both sexes in Central Europe and Number of enrolments of both sexes in Gambia, The?
Make the answer very short. 9.43e+06. In the year 1980, what is the difference between the Number of enrolments of both sexes in Central Europe and Number of enrolments of both sexes in Guinea-Bissau?
Your answer should be very brief. 9.44e+06. In the year 1980, what is the difference between the Number of enrolments of both sexes of Central Europe and Number of enrolments of both sexes of Poland?
Make the answer very short. 6.73e+06. In the year 1980, what is the difference between the Number of enrolments of both sexes of Gambia, The and Number of enrolments of both sexes of Guinea-Bissau?
Your response must be concise. 4684. In the year 1980, what is the difference between the Number of enrolments of both sexes of Gambia, The and Number of enrolments of both sexes of Poland?
Your response must be concise. -2.70e+06. In the year 1980, what is the difference between the Number of enrolments of both sexes in Guinea-Bissau and Number of enrolments of both sexes in Poland?
Give a very brief answer. -2.71e+06. In the year 1981, what is the difference between the Number of enrolments of both sexes of Central Europe and Number of enrolments of both sexes of Gambia, The?
Offer a terse response. 9.69e+06. In the year 1981, what is the difference between the Number of enrolments of both sexes in Central Europe and Number of enrolments of both sexes in Guinea-Bissau?
Provide a succinct answer. 9.70e+06. In the year 1981, what is the difference between the Number of enrolments of both sexes of Central Europe and Number of enrolments of both sexes of Poland?
Offer a terse response. 7.05e+06. In the year 1981, what is the difference between the Number of enrolments of both sexes of Gambia, The and Number of enrolments of both sexes of Guinea-Bissau?
Your answer should be very brief. 4900. In the year 1981, what is the difference between the Number of enrolments of both sexes in Gambia, The and Number of enrolments of both sexes in Poland?
Your answer should be very brief. -2.64e+06. In the year 1981, what is the difference between the Number of enrolments of both sexes of Guinea-Bissau and Number of enrolments of both sexes of Poland?
Your answer should be very brief. -2.65e+06. In the year 1982, what is the difference between the Number of enrolments of both sexes in Central Europe and Number of enrolments of both sexes in Gambia, The?
Provide a succinct answer. 9.95e+06. In the year 1982, what is the difference between the Number of enrolments of both sexes in Central Europe and Number of enrolments of both sexes in Guinea-Bissau?
Your response must be concise. 9.95e+06. In the year 1982, what is the difference between the Number of enrolments of both sexes in Central Europe and Number of enrolments of both sexes in Poland?
Keep it short and to the point. 7.40e+06. In the year 1982, what is the difference between the Number of enrolments of both sexes in Gambia, The and Number of enrolments of both sexes in Guinea-Bissau?
Your answer should be very brief. 4275. In the year 1982, what is the difference between the Number of enrolments of both sexes in Gambia, The and Number of enrolments of both sexes in Poland?
Your answer should be compact. -2.54e+06. In the year 1982, what is the difference between the Number of enrolments of both sexes in Guinea-Bissau and Number of enrolments of both sexes in Poland?
Give a very brief answer. -2.55e+06. In the year 1983, what is the difference between the Number of enrolments of both sexes of Central Europe and Number of enrolments of both sexes of Gambia, The?
Your answer should be compact. 1.02e+07. In the year 1983, what is the difference between the Number of enrolments of both sexes in Central Europe and Number of enrolments of both sexes in Guinea-Bissau?
Your answer should be compact. 1.02e+07. In the year 1983, what is the difference between the Number of enrolments of both sexes in Central Europe and Number of enrolments of both sexes in Poland?
Provide a short and direct response. 7.71e+06. In the year 1983, what is the difference between the Number of enrolments of both sexes of Gambia, The and Number of enrolments of both sexes of Guinea-Bissau?
Your answer should be compact. 3992. In the year 1983, what is the difference between the Number of enrolments of both sexes in Gambia, The and Number of enrolments of both sexes in Poland?
Keep it short and to the point. -2.47e+06. In the year 1983, what is the difference between the Number of enrolments of both sexes in Guinea-Bissau and Number of enrolments of both sexes in Poland?
Offer a terse response. -2.47e+06. In the year 1984, what is the difference between the Number of enrolments of both sexes in Central Europe and Number of enrolments of both sexes in Gambia, The?
Offer a terse response. 1.04e+07. In the year 1984, what is the difference between the Number of enrolments of both sexes in Central Europe and Number of enrolments of both sexes in Guinea-Bissau?
Ensure brevity in your answer.  1.04e+07. In the year 1984, what is the difference between the Number of enrolments of both sexes in Central Europe and Number of enrolments of both sexes in Poland?
Offer a terse response. 7.95e+06. In the year 1984, what is the difference between the Number of enrolments of both sexes of Gambia, The and Number of enrolments of both sexes of Guinea-Bissau?
Keep it short and to the point. 4796. In the year 1984, what is the difference between the Number of enrolments of both sexes in Gambia, The and Number of enrolments of both sexes in Poland?
Ensure brevity in your answer.  -2.47e+06. In the year 1984, what is the difference between the Number of enrolments of both sexes of Guinea-Bissau and Number of enrolments of both sexes of Poland?
Provide a short and direct response. -2.48e+06. What is the ratio of the Number of enrolments of both sexes of Gambia, The in 1978 to that in 1979?
Provide a short and direct response. 0.94. What is the ratio of the Number of enrolments of both sexes in Guinea-Bissau in 1978 to that in 1979?
Give a very brief answer. 0.87. What is the ratio of the Number of enrolments of both sexes of Poland in 1978 to that in 1979?
Offer a terse response. 1.04. What is the ratio of the Number of enrolments of both sexes of Gambia, The in 1978 to that in 1980?
Keep it short and to the point. 0.85. What is the ratio of the Number of enrolments of both sexes in Guinea-Bissau in 1978 to that in 1980?
Offer a very short reply. 0.88. What is the ratio of the Number of enrolments of both sexes of Poland in 1978 to that in 1980?
Provide a short and direct response. 1.07. What is the ratio of the Number of enrolments of both sexes in Central Europe in 1978 to that in 1981?
Give a very brief answer. 0.97. What is the ratio of the Number of enrolments of both sexes in Gambia, The in 1978 to that in 1981?
Provide a short and direct response. 0.79. What is the ratio of the Number of enrolments of both sexes in Guinea-Bissau in 1978 to that in 1981?
Offer a terse response. 0.78. What is the ratio of the Number of enrolments of both sexes of Poland in 1978 to that in 1981?
Keep it short and to the point. 1.09. What is the ratio of the Number of enrolments of both sexes of Central Europe in 1978 to that in 1982?
Provide a short and direct response. 0.94. What is the ratio of the Number of enrolments of both sexes of Gambia, The in 1978 to that in 1982?
Provide a succinct answer. 0.72. What is the ratio of the Number of enrolments of both sexes in Guinea-Bissau in 1978 to that in 1982?
Give a very brief answer. 0.59. What is the ratio of the Number of enrolments of both sexes of Poland in 1978 to that in 1982?
Ensure brevity in your answer.  1.14. What is the ratio of the Number of enrolments of both sexes in Central Europe in 1978 to that in 1983?
Keep it short and to the point. 0.92. What is the ratio of the Number of enrolments of both sexes in Gambia, The in 1978 to that in 1983?
Provide a succinct answer. 0.61. What is the ratio of the Number of enrolments of both sexes of Guinea-Bissau in 1978 to that in 1983?
Provide a short and direct response. 0.44. What is the ratio of the Number of enrolments of both sexes of Poland in 1978 to that in 1983?
Ensure brevity in your answer.  1.17. What is the ratio of the Number of enrolments of both sexes of Central Europe in 1978 to that in 1984?
Make the answer very short. 0.9. What is the ratio of the Number of enrolments of both sexes of Gambia, The in 1978 to that in 1984?
Offer a terse response. 0.53. What is the ratio of the Number of enrolments of both sexes in Guinea-Bissau in 1978 to that in 1984?
Provide a short and direct response. 0.39. What is the ratio of the Number of enrolments of both sexes of Poland in 1978 to that in 1984?
Ensure brevity in your answer.  1.17. What is the ratio of the Number of enrolments of both sexes in Central Europe in 1979 to that in 1980?
Ensure brevity in your answer.  0.99. What is the ratio of the Number of enrolments of both sexes of Gambia, The in 1979 to that in 1980?
Offer a very short reply. 0.91. What is the ratio of the Number of enrolments of both sexes in Guinea-Bissau in 1979 to that in 1980?
Your answer should be compact. 1.01. What is the ratio of the Number of enrolments of both sexes in Poland in 1979 to that in 1980?
Give a very brief answer. 1.03. What is the ratio of the Number of enrolments of both sexes in Central Europe in 1979 to that in 1981?
Provide a succinct answer. 0.96. What is the ratio of the Number of enrolments of both sexes in Gambia, The in 1979 to that in 1981?
Your answer should be compact. 0.84. What is the ratio of the Number of enrolments of both sexes of Guinea-Bissau in 1979 to that in 1981?
Provide a succinct answer. 0.9. What is the ratio of the Number of enrolments of both sexes in Poland in 1979 to that in 1981?
Your response must be concise. 1.06. What is the ratio of the Number of enrolments of both sexes of Central Europe in 1979 to that in 1982?
Offer a very short reply. 0.94. What is the ratio of the Number of enrolments of both sexes of Gambia, The in 1979 to that in 1982?
Make the answer very short. 0.77. What is the ratio of the Number of enrolments of both sexes of Guinea-Bissau in 1979 to that in 1982?
Make the answer very short. 0.68. What is the ratio of the Number of enrolments of both sexes of Poland in 1979 to that in 1982?
Keep it short and to the point. 1.1. What is the ratio of the Number of enrolments of both sexes of Central Europe in 1979 to that in 1983?
Ensure brevity in your answer.  0.92. What is the ratio of the Number of enrolments of both sexes in Gambia, The in 1979 to that in 1983?
Your answer should be very brief. 0.65. What is the ratio of the Number of enrolments of both sexes in Guinea-Bissau in 1979 to that in 1983?
Ensure brevity in your answer.  0.51. What is the ratio of the Number of enrolments of both sexes in Poland in 1979 to that in 1983?
Offer a very short reply. 1.13. What is the ratio of the Number of enrolments of both sexes in Central Europe in 1979 to that in 1984?
Offer a terse response. 0.9. What is the ratio of the Number of enrolments of both sexes of Gambia, The in 1979 to that in 1984?
Give a very brief answer. 0.56. What is the ratio of the Number of enrolments of both sexes of Guinea-Bissau in 1979 to that in 1984?
Your response must be concise. 0.45. What is the ratio of the Number of enrolments of both sexes of Poland in 1979 to that in 1984?
Your answer should be very brief. 1.13. What is the ratio of the Number of enrolments of both sexes in Central Europe in 1980 to that in 1981?
Offer a terse response. 0.97. What is the ratio of the Number of enrolments of both sexes in Gambia, The in 1980 to that in 1981?
Provide a short and direct response. 0.93. What is the ratio of the Number of enrolments of both sexes of Guinea-Bissau in 1980 to that in 1981?
Give a very brief answer. 0.89. What is the ratio of the Number of enrolments of both sexes in Poland in 1980 to that in 1981?
Provide a succinct answer. 1.02. What is the ratio of the Number of enrolments of both sexes in Central Europe in 1980 to that in 1982?
Offer a terse response. 0.95. What is the ratio of the Number of enrolments of both sexes of Gambia, The in 1980 to that in 1982?
Provide a succinct answer. 0.85. What is the ratio of the Number of enrolments of both sexes of Guinea-Bissau in 1980 to that in 1982?
Offer a very short reply. 0.68. What is the ratio of the Number of enrolments of both sexes in Poland in 1980 to that in 1982?
Make the answer very short. 1.06. What is the ratio of the Number of enrolments of both sexes of Central Europe in 1980 to that in 1983?
Keep it short and to the point. 0.93. What is the ratio of the Number of enrolments of both sexes in Gambia, The in 1980 to that in 1983?
Offer a very short reply. 0.72. What is the ratio of the Number of enrolments of both sexes in Guinea-Bissau in 1980 to that in 1983?
Make the answer very short. 0.5. What is the ratio of the Number of enrolments of both sexes in Poland in 1980 to that in 1983?
Give a very brief answer. 1.09. What is the ratio of the Number of enrolments of both sexes in Central Europe in 1980 to that in 1984?
Your answer should be compact. 0.9. What is the ratio of the Number of enrolments of both sexes in Gambia, The in 1980 to that in 1984?
Ensure brevity in your answer.  0.62. What is the ratio of the Number of enrolments of both sexes in Guinea-Bissau in 1980 to that in 1984?
Provide a short and direct response. 0.44. What is the ratio of the Number of enrolments of both sexes in Poland in 1980 to that in 1984?
Your answer should be very brief. 1.09. What is the ratio of the Number of enrolments of both sexes of Central Europe in 1981 to that in 1982?
Offer a very short reply. 0.97. What is the ratio of the Number of enrolments of both sexes in Gambia, The in 1981 to that in 1982?
Keep it short and to the point. 0.91. What is the ratio of the Number of enrolments of both sexes in Guinea-Bissau in 1981 to that in 1982?
Ensure brevity in your answer.  0.76. What is the ratio of the Number of enrolments of both sexes in Poland in 1981 to that in 1982?
Your answer should be very brief. 1.04. What is the ratio of the Number of enrolments of both sexes in Central Europe in 1981 to that in 1983?
Provide a short and direct response. 0.95. What is the ratio of the Number of enrolments of both sexes of Gambia, The in 1981 to that in 1983?
Your answer should be very brief. 0.78. What is the ratio of the Number of enrolments of both sexes of Guinea-Bissau in 1981 to that in 1983?
Your answer should be very brief. 0.56. What is the ratio of the Number of enrolments of both sexes of Poland in 1981 to that in 1983?
Provide a succinct answer. 1.07. What is the ratio of the Number of enrolments of both sexes of Central Europe in 1981 to that in 1984?
Offer a very short reply. 0.93. What is the ratio of the Number of enrolments of both sexes in Gambia, The in 1981 to that in 1984?
Make the answer very short. 0.67. What is the ratio of the Number of enrolments of both sexes in Guinea-Bissau in 1981 to that in 1984?
Provide a short and direct response. 0.49. What is the ratio of the Number of enrolments of both sexes in Poland in 1981 to that in 1984?
Offer a very short reply. 1.06. What is the ratio of the Number of enrolments of both sexes in Central Europe in 1982 to that in 1983?
Ensure brevity in your answer.  0.98. What is the ratio of the Number of enrolments of both sexes of Gambia, The in 1982 to that in 1983?
Offer a very short reply. 0.85. What is the ratio of the Number of enrolments of both sexes in Guinea-Bissau in 1982 to that in 1983?
Make the answer very short. 0.75. What is the ratio of the Number of enrolments of both sexes of Poland in 1982 to that in 1983?
Your answer should be very brief. 1.03. What is the ratio of the Number of enrolments of both sexes of Central Europe in 1982 to that in 1984?
Your response must be concise. 0.95. What is the ratio of the Number of enrolments of both sexes of Gambia, The in 1982 to that in 1984?
Give a very brief answer. 0.73. What is the ratio of the Number of enrolments of both sexes of Guinea-Bissau in 1982 to that in 1984?
Provide a short and direct response. 0.65. What is the ratio of the Number of enrolments of both sexes of Poland in 1982 to that in 1984?
Provide a short and direct response. 1.03. What is the ratio of the Number of enrolments of both sexes in Central Europe in 1983 to that in 1984?
Offer a very short reply. 0.98. What is the ratio of the Number of enrolments of both sexes of Gambia, The in 1983 to that in 1984?
Give a very brief answer. 0.86. What is the ratio of the Number of enrolments of both sexes in Guinea-Bissau in 1983 to that in 1984?
Your answer should be very brief. 0.88. What is the difference between the highest and the second highest Number of enrolments of both sexes in Central Europe?
Keep it short and to the point. 2.53e+05. What is the difference between the highest and the second highest Number of enrolments of both sexes in Gambia, The?
Your answer should be very brief. 2006. What is the difference between the highest and the second highest Number of enrolments of both sexes of Guinea-Bissau?
Keep it short and to the point. 1202. What is the difference between the highest and the second highest Number of enrolments of both sexes in Poland?
Your response must be concise. 1.01e+05. What is the difference between the highest and the lowest Number of enrolments of both sexes of Central Europe?
Provide a short and direct response. 1.09e+06. What is the difference between the highest and the lowest Number of enrolments of both sexes in Gambia, The?
Keep it short and to the point. 6842. What is the difference between the highest and the lowest Number of enrolments of both sexes of Guinea-Bissau?
Keep it short and to the point. 5903. What is the difference between the highest and the lowest Number of enrolments of both sexes of Poland?
Provide a short and direct response. 4.22e+05. 